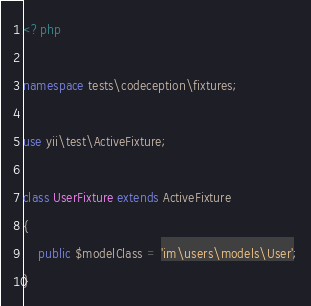<code> <loc_0><loc_0><loc_500><loc_500><_PHP_><?php

namespace tests\codeception\fixtures;

use yii\test\ActiveFixture;

class UserFixture extends ActiveFixture
{
    public $modelClass = 'im\users\models\User';
}
</code> 